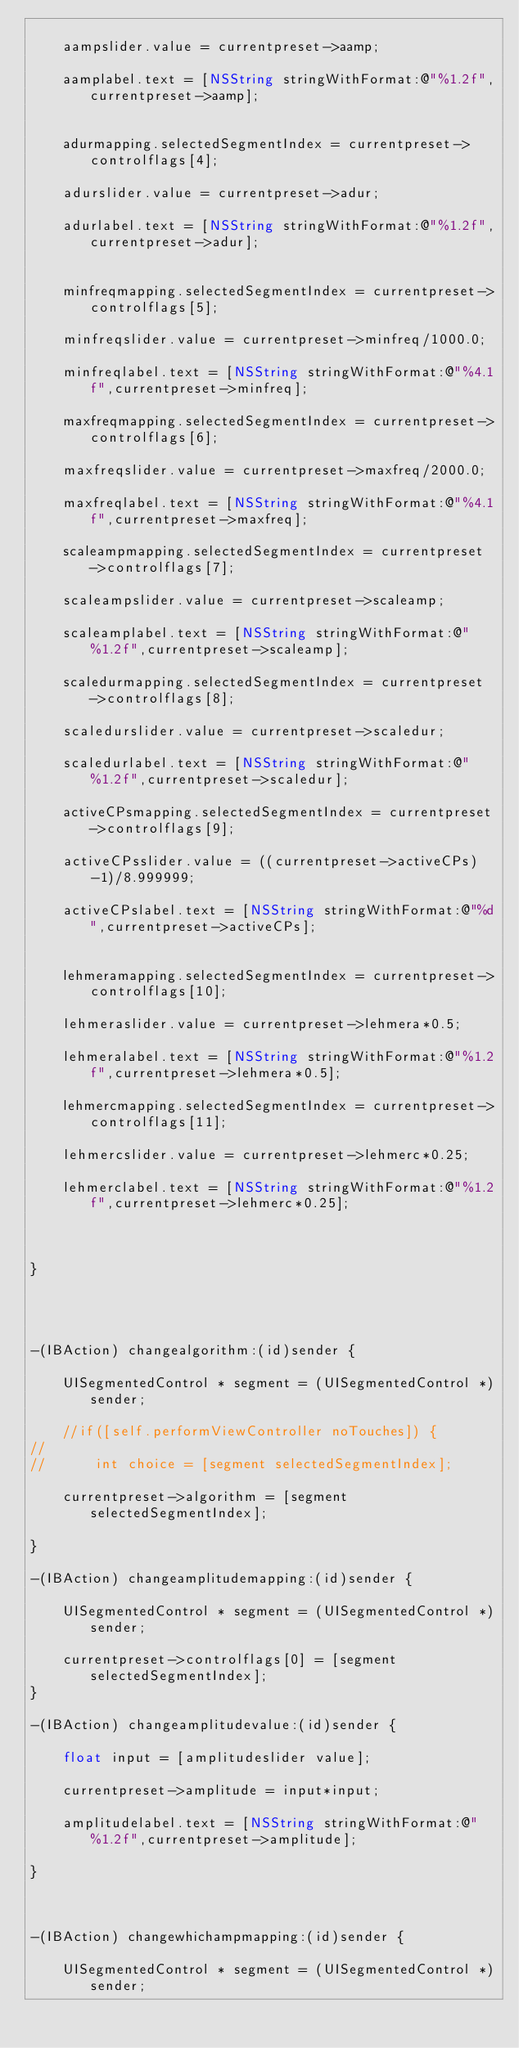<code> <loc_0><loc_0><loc_500><loc_500><_ObjectiveC_>	
	aampslider.value = currentpreset->aamp;
	
	aamplabel.text = [NSString stringWithFormat:@"%1.2f",currentpreset->aamp];
	
	
	adurmapping.selectedSegmentIndex = currentpreset->controlflags[4]; 
	
	adurslider.value = currentpreset->adur;
	
	adurlabel.text = [NSString stringWithFormat:@"%1.2f",currentpreset->adur];
	
	
	minfreqmapping.selectedSegmentIndex = currentpreset->controlflags[5]; 
	
	minfreqslider.value = currentpreset->minfreq/1000.0;
	
	minfreqlabel.text = [NSString stringWithFormat:@"%4.1f",currentpreset->minfreq];
	
	maxfreqmapping.selectedSegmentIndex = currentpreset->controlflags[6]; 
	
	maxfreqslider.value = currentpreset->maxfreq/2000.0;
	
	maxfreqlabel.text = [NSString stringWithFormat:@"%4.1f",currentpreset->maxfreq];
	
	scaleampmapping.selectedSegmentIndex = currentpreset->controlflags[7]; 
	
	scaleampslider.value = currentpreset->scaleamp;
	
	scaleamplabel.text = [NSString stringWithFormat:@"%1.2f",currentpreset->scaleamp];
	
	scaledurmapping.selectedSegmentIndex = currentpreset->controlflags[8]; 
	
	scaledurslider.value = currentpreset->scaledur;
	
	scaledurlabel.text = [NSString stringWithFormat:@"%1.2f",currentpreset->scaledur];

	activeCPsmapping.selectedSegmentIndex = currentpreset->controlflags[9]; 
	
	activeCPsslider.value = ((currentpreset->activeCPs)-1)/8.999999;
	
	activeCPslabel.text = [NSString stringWithFormat:@"%d",currentpreset->activeCPs];

	
	lehmeramapping.selectedSegmentIndex = currentpreset->controlflags[10]; 
	
	lehmeraslider.value = currentpreset->lehmera*0.5;
	
	lehmeralabel.text = [NSString stringWithFormat:@"%1.2f",currentpreset->lehmera*0.5];
	
	lehmercmapping.selectedSegmentIndex = currentpreset->controlflags[11]; 
	
	lehmercslider.value = currentpreset->lehmerc*0.25;
	
	lehmerclabel.text = [NSString stringWithFormat:@"%1.2f",currentpreset->lehmerc*0.25];
	
	
	
}




-(IBAction) changealgorithm:(id)sender {
	
	UISegmentedControl * segment = (UISegmentedControl *)sender; 
	
	//if([self.performViewController noTouches]) {
//		
//		int choice = [segment selectedSegmentIndex]; 
	
	currentpreset->algorithm = [segment selectedSegmentIndex];  
	
}

-(IBAction) changeamplitudemapping:(id)sender {
	
	UISegmentedControl * segment = (UISegmentedControl *)sender; 
	
	currentpreset->controlflags[0] = [segment selectedSegmentIndex]; 
}

-(IBAction) changeamplitudevalue:(id)sender {
	
	float input = [amplitudeslider value]; 
	
	currentpreset->amplitude = input*input; 

	amplitudelabel.text = [NSString stringWithFormat:@"%1.2f",currentpreset->amplitude];
	
}



-(IBAction) changewhichampmapping:(id)sender {
	
	UISegmentedControl * segment = (UISegmentedControl *)sender; 
	</code> 